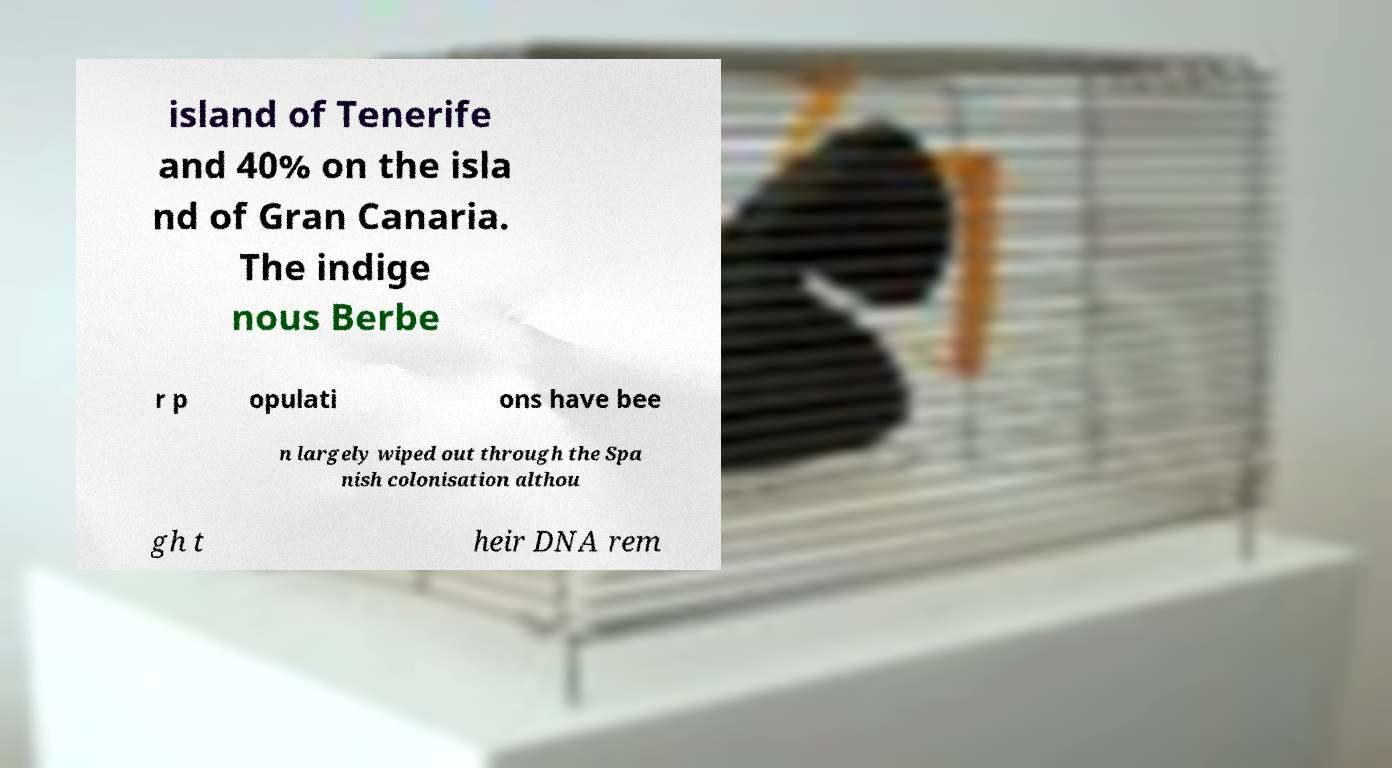Please identify and transcribe the text found in this image. island of Tenerife and 40% on the isla nd of Gran Canaria. The indige nous Berbe r p opulati ons have bee n largely wiped out through the Spa nish colonisation althou gh t heir DNA rem 